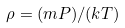Convert formula to latex. <formula><loc_0><loc_0><loc_500><loc_500>\rho = ( m P ) / ( k T )</formula> 